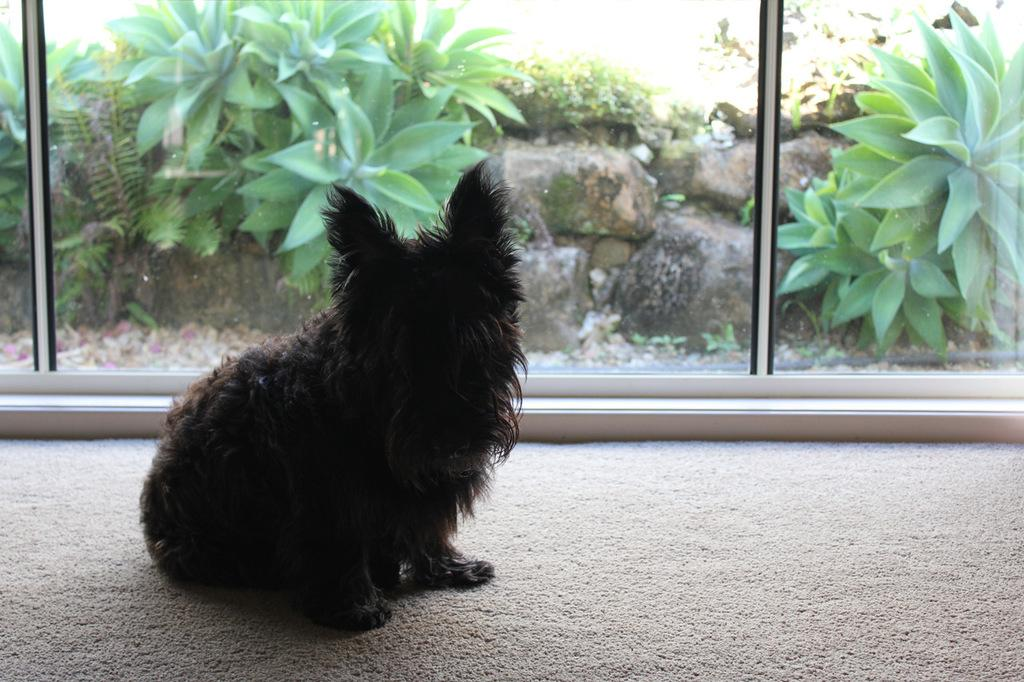What animal can be seen on the left side of the image? There is a cat on the left side of the image. What architectural feature is located in the center of the image? There is a window in the center of the image. What can be seen through the window? Plants are visible in the window. How many ants are crawling on the kettle in the image? There is no kettle present in the image, and therefore no ants can be observed. 